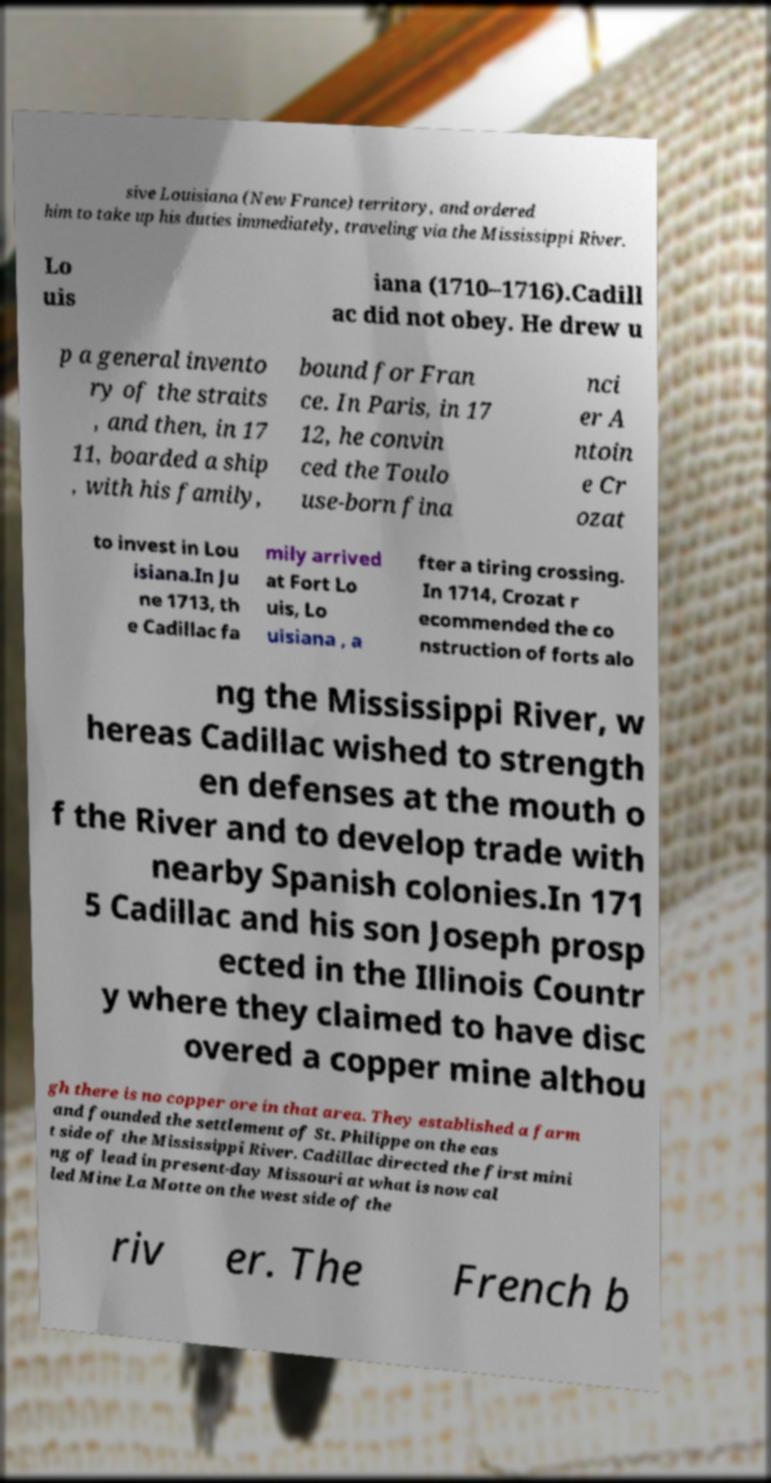Could you extract and type out the text from this image? sive Louisiana (New France) territory, and ordered him to take up his duties immediately, traveling via the Mississippi River. Lo uis iana (1710–1716).Cadill ac did not obey. He drew u p a general invento ry of the straits , and then, in 17 11, boarded a ship , with his family, bound for Fran ce. In Paris, in 17 12, he convin ced the Toulo use-born fina nci er A ntoin e Cr ozat to invest in Lou isiana.In Ju ne 1713, th e Cadillac fa mily arrived at Fort Lo uis, Lo uisiana , a fter a tiring crossing. In 1714, Crozat r ecommended the co nstruction of forts alo ng the Mississippi River, w hereas Cadillac wished to strength en defenses at the mouth o f the River and to develop trade with nearby Spanish colonies.In 171 5 Cadillac and his son Joseph prosp ected in the Illinois Countr y where they claimed to have disc overed a copper mine althou gh there is no copper ore in that area. They established a farm and founded the settlement of St. Philippe on the eas t side of the Mississippi River. Cadillac directed the first mini ng of lead in present-day Missouri at what is now cal led Mine La Motte on the west side of the riv er. The French b 